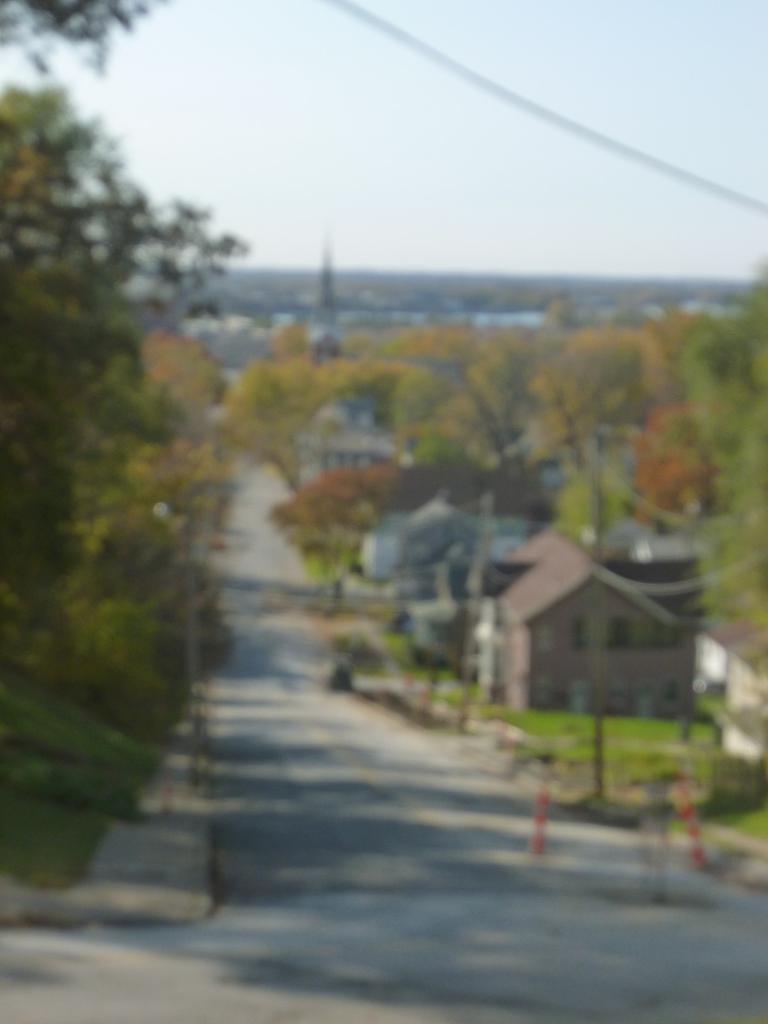Can you describe this image briefly? In this picture we can see a building here, there are some trees here, we can see grass at the right bottom, there is the sky at the top of the picture. 